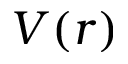Convert formula to latex. <formula><loc_0><loc_0><loc_500><loc_500>V ( r )</formula> 